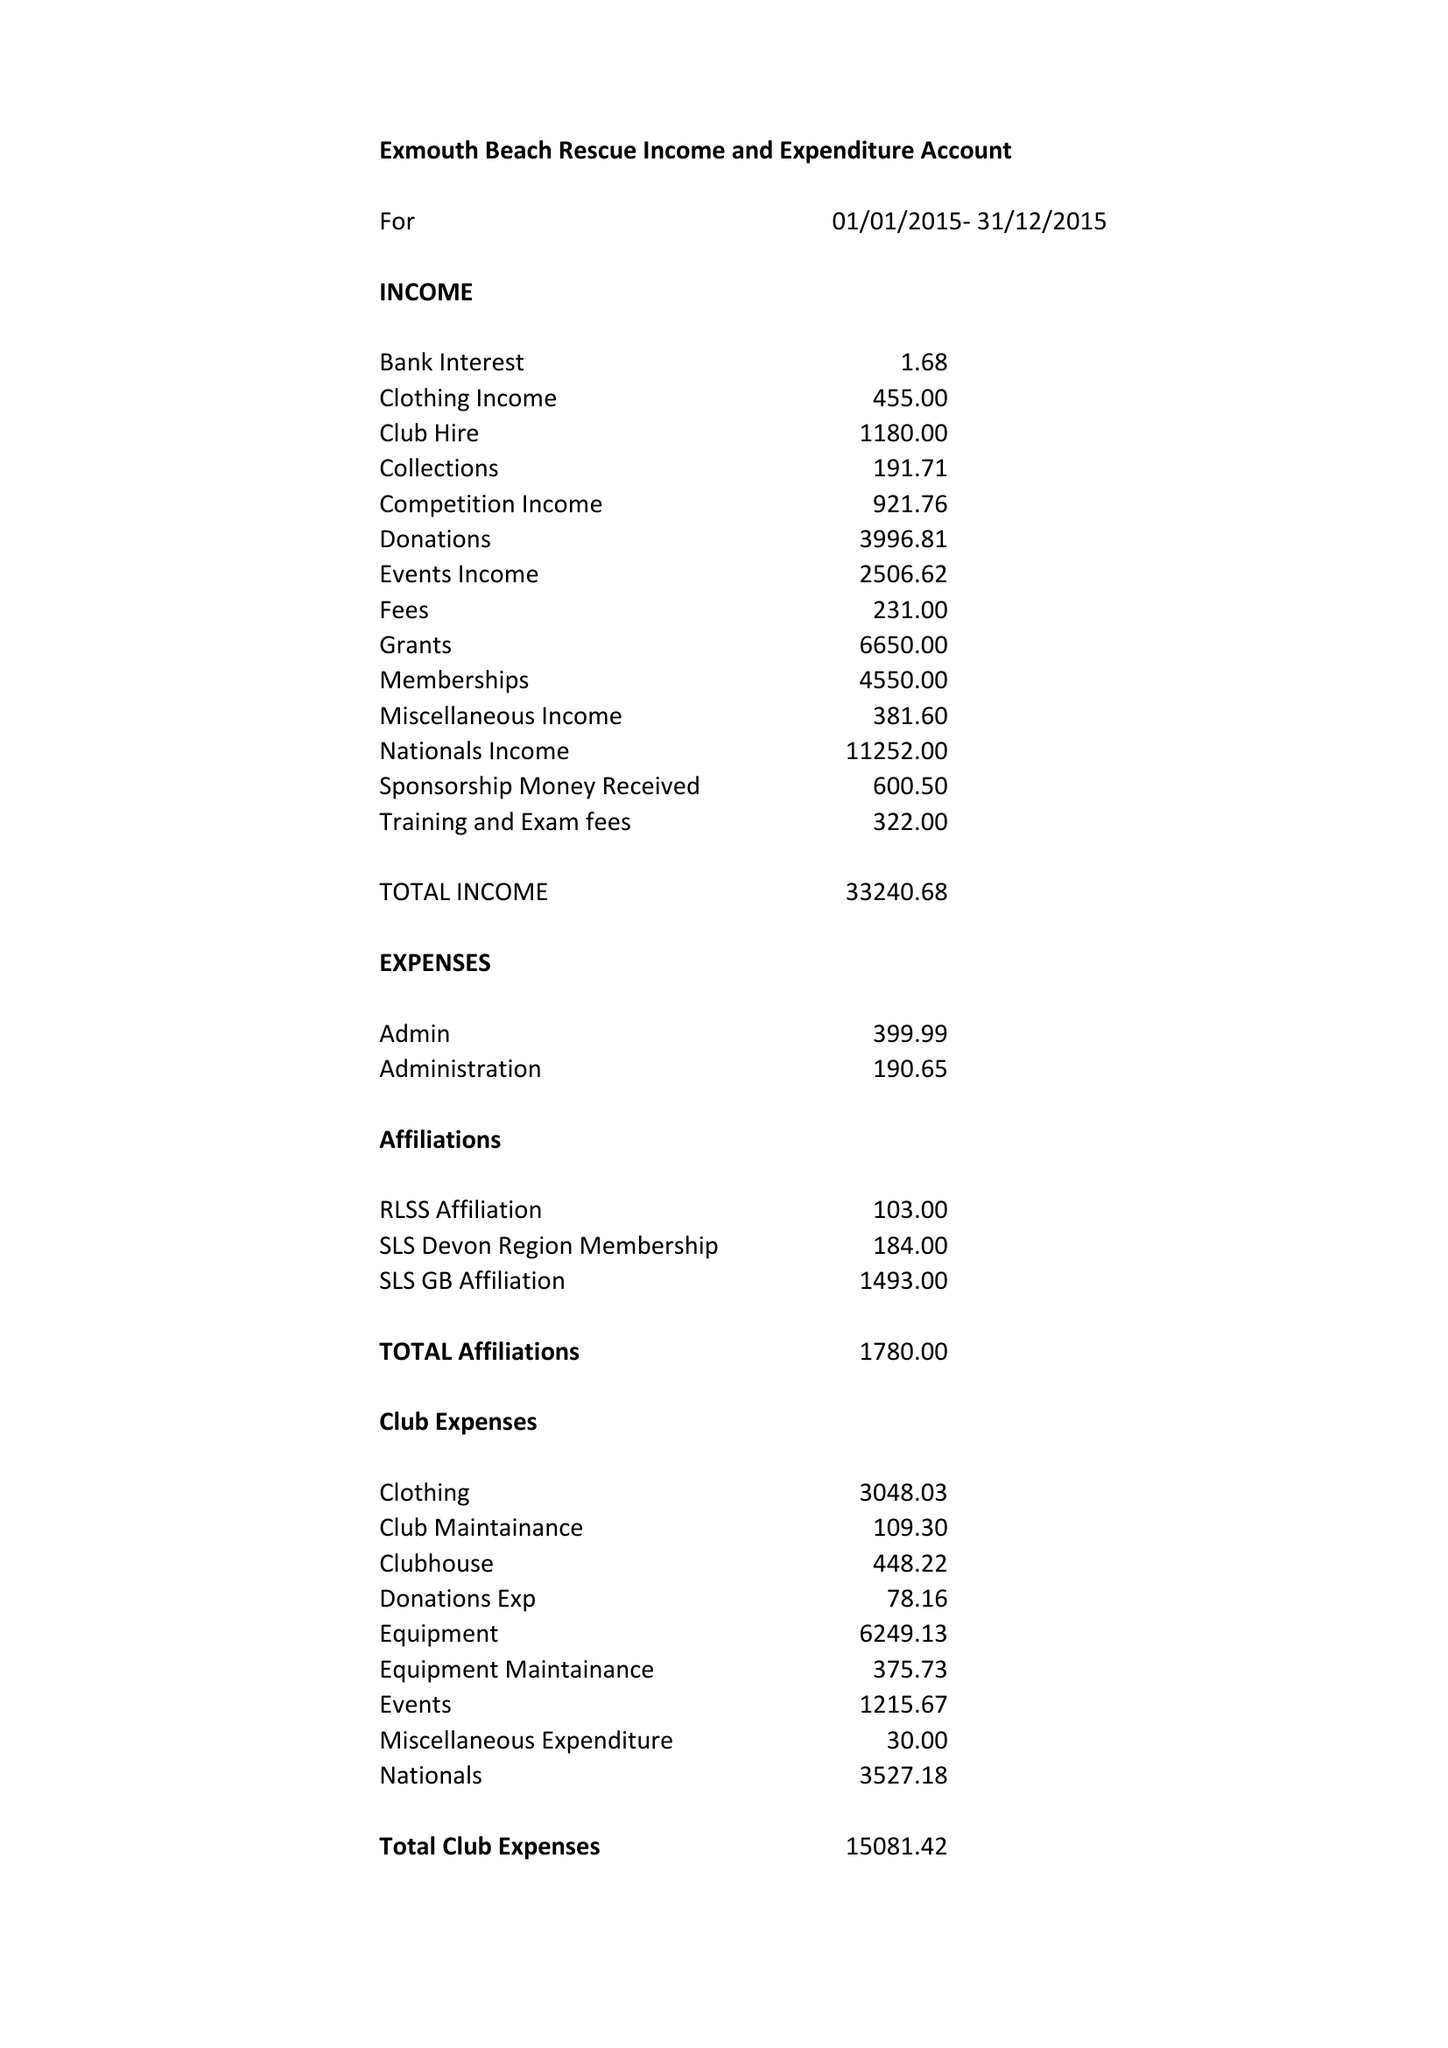What is the value for the address__street_line?
Answer the question using a single word or phrase. 86 BRIXINGTON LANE 